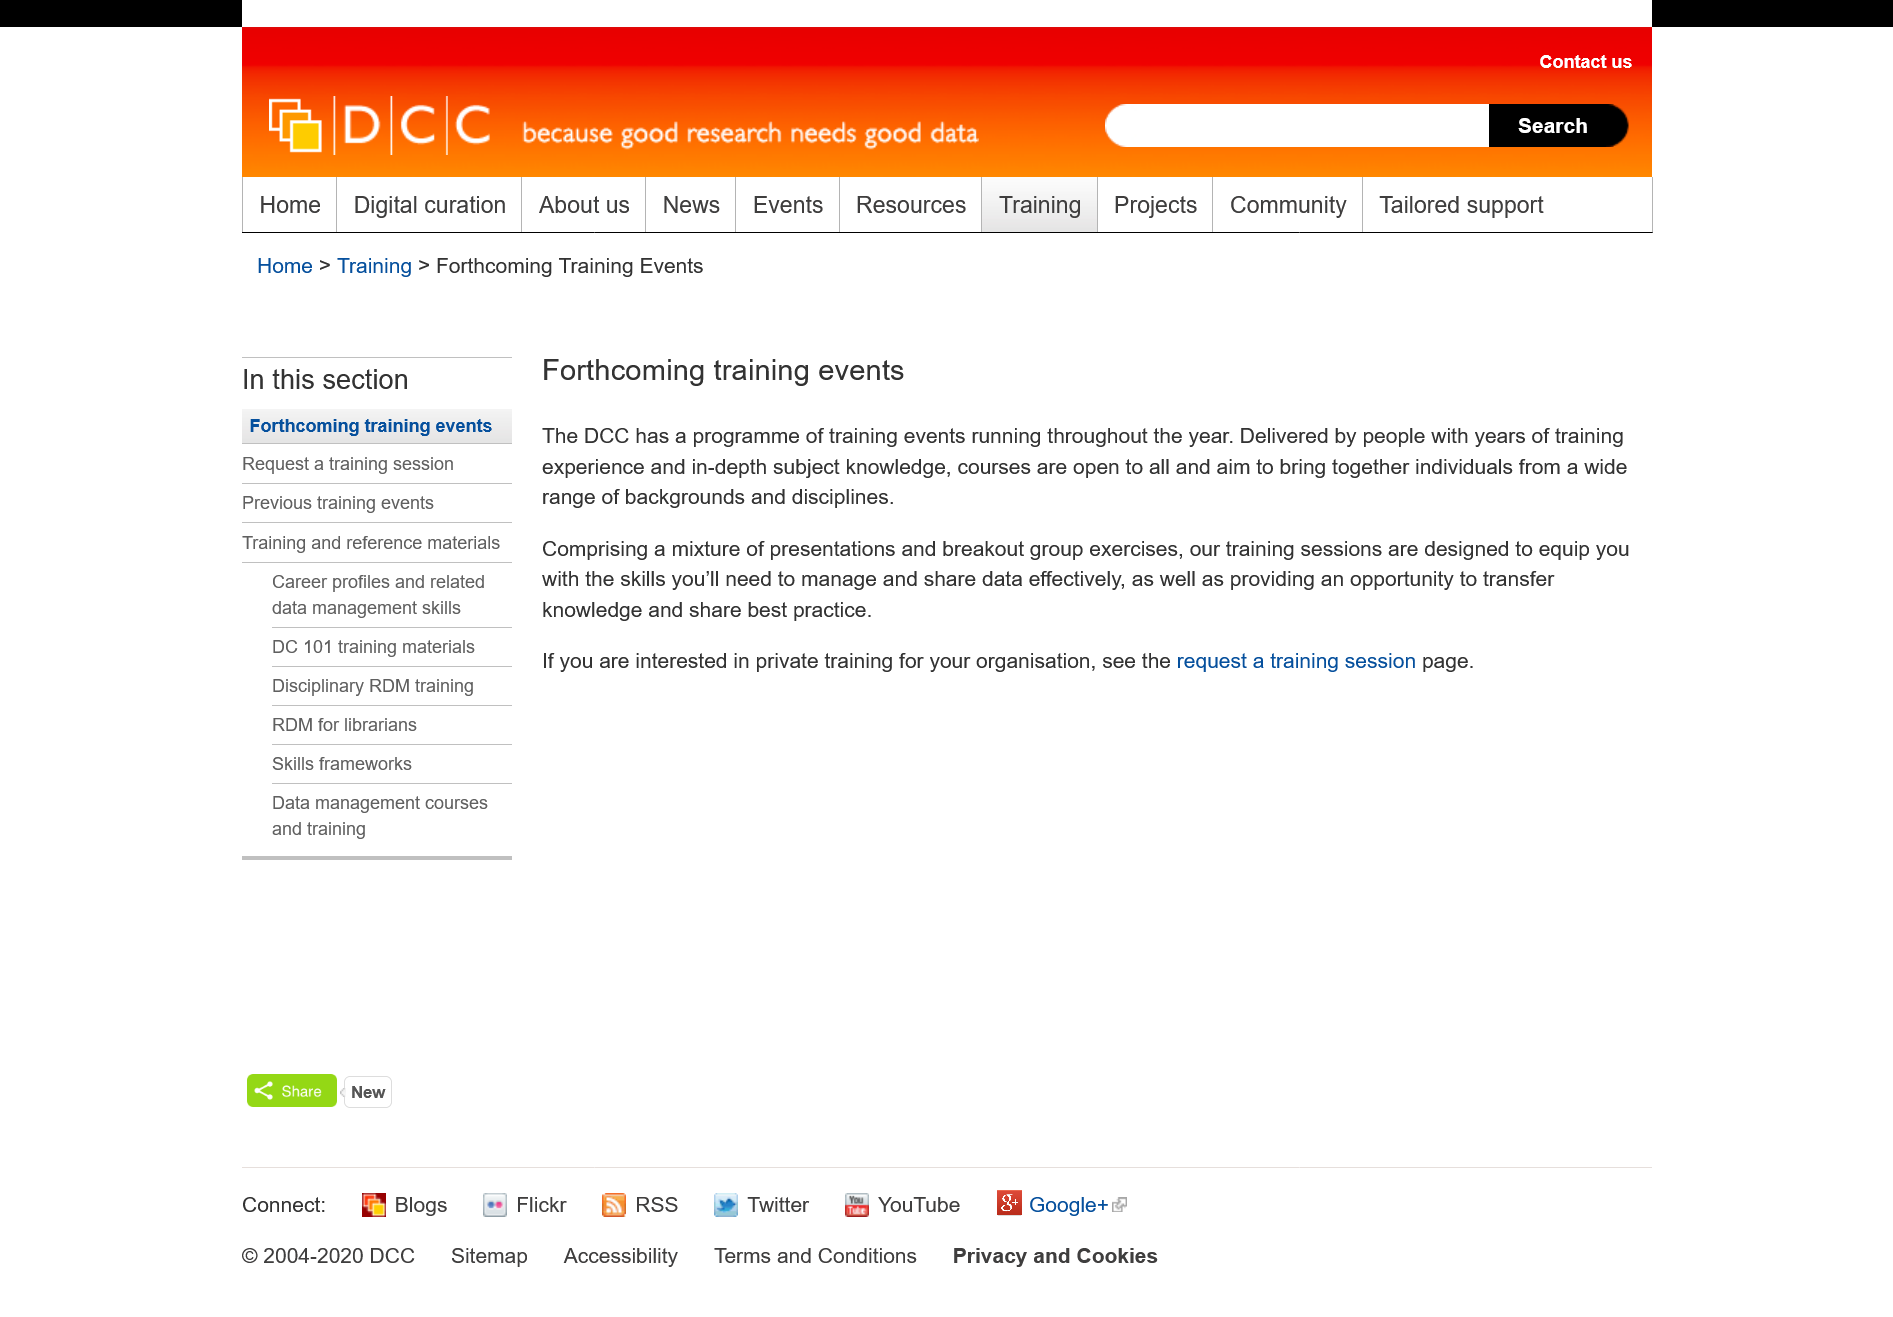Point out several critical features in this image. The DCC has a comprehensive training program slated for the entire year, and upcoming training events are scheduled to take place soon. DCC training events are open to all individuals without discrimination. If you are seeking information on private training for your organization, please visit the "request a training session" page. 